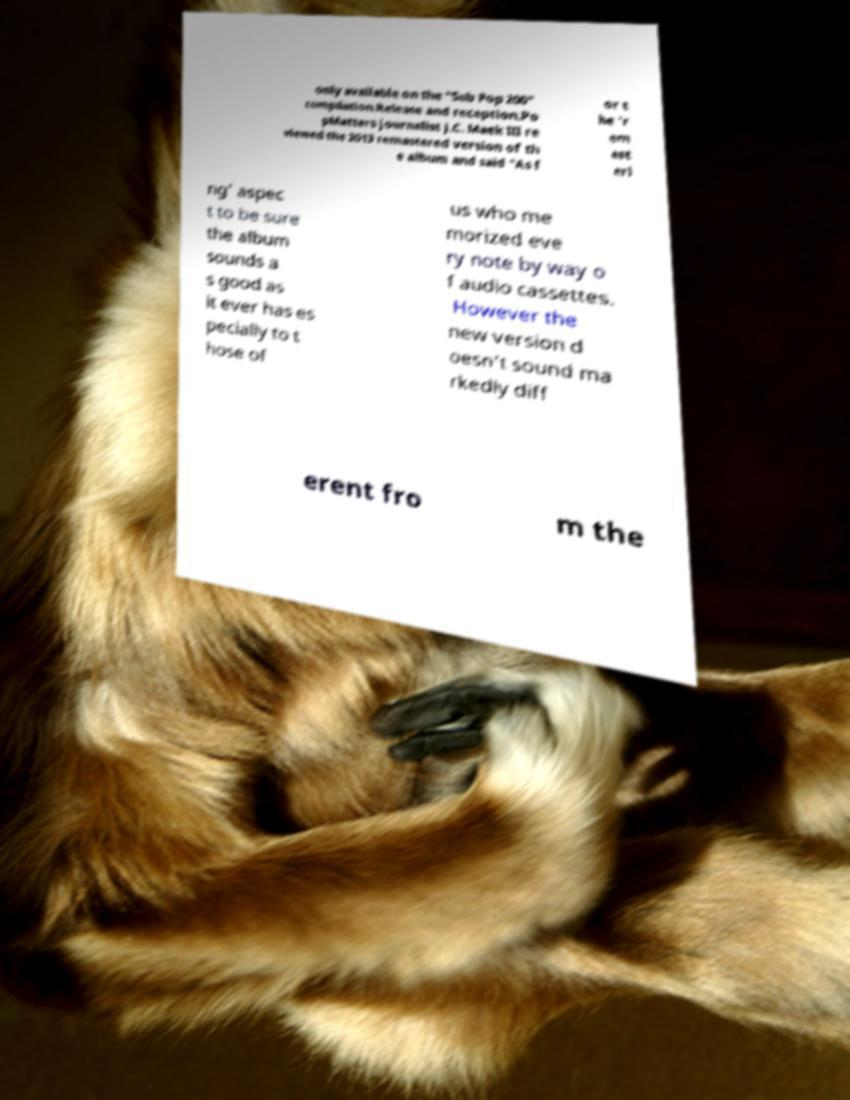I need the written content from this picture converted into text. Can you do that? only available on the "Sub Pop 200" compilation.Release and reception.Po pMatters journalist J.C. Maek III re viewed the 2013 remastered version of th e album and said "As f or t he 'r em ast eri ng' aspec t to be sure the album sounds a s good as it ever has es pecially to t hose of us who me morized eve ry note by way o f audio cassettes. However the new version d oesn't sound ma rkedly diff erent fro m the 